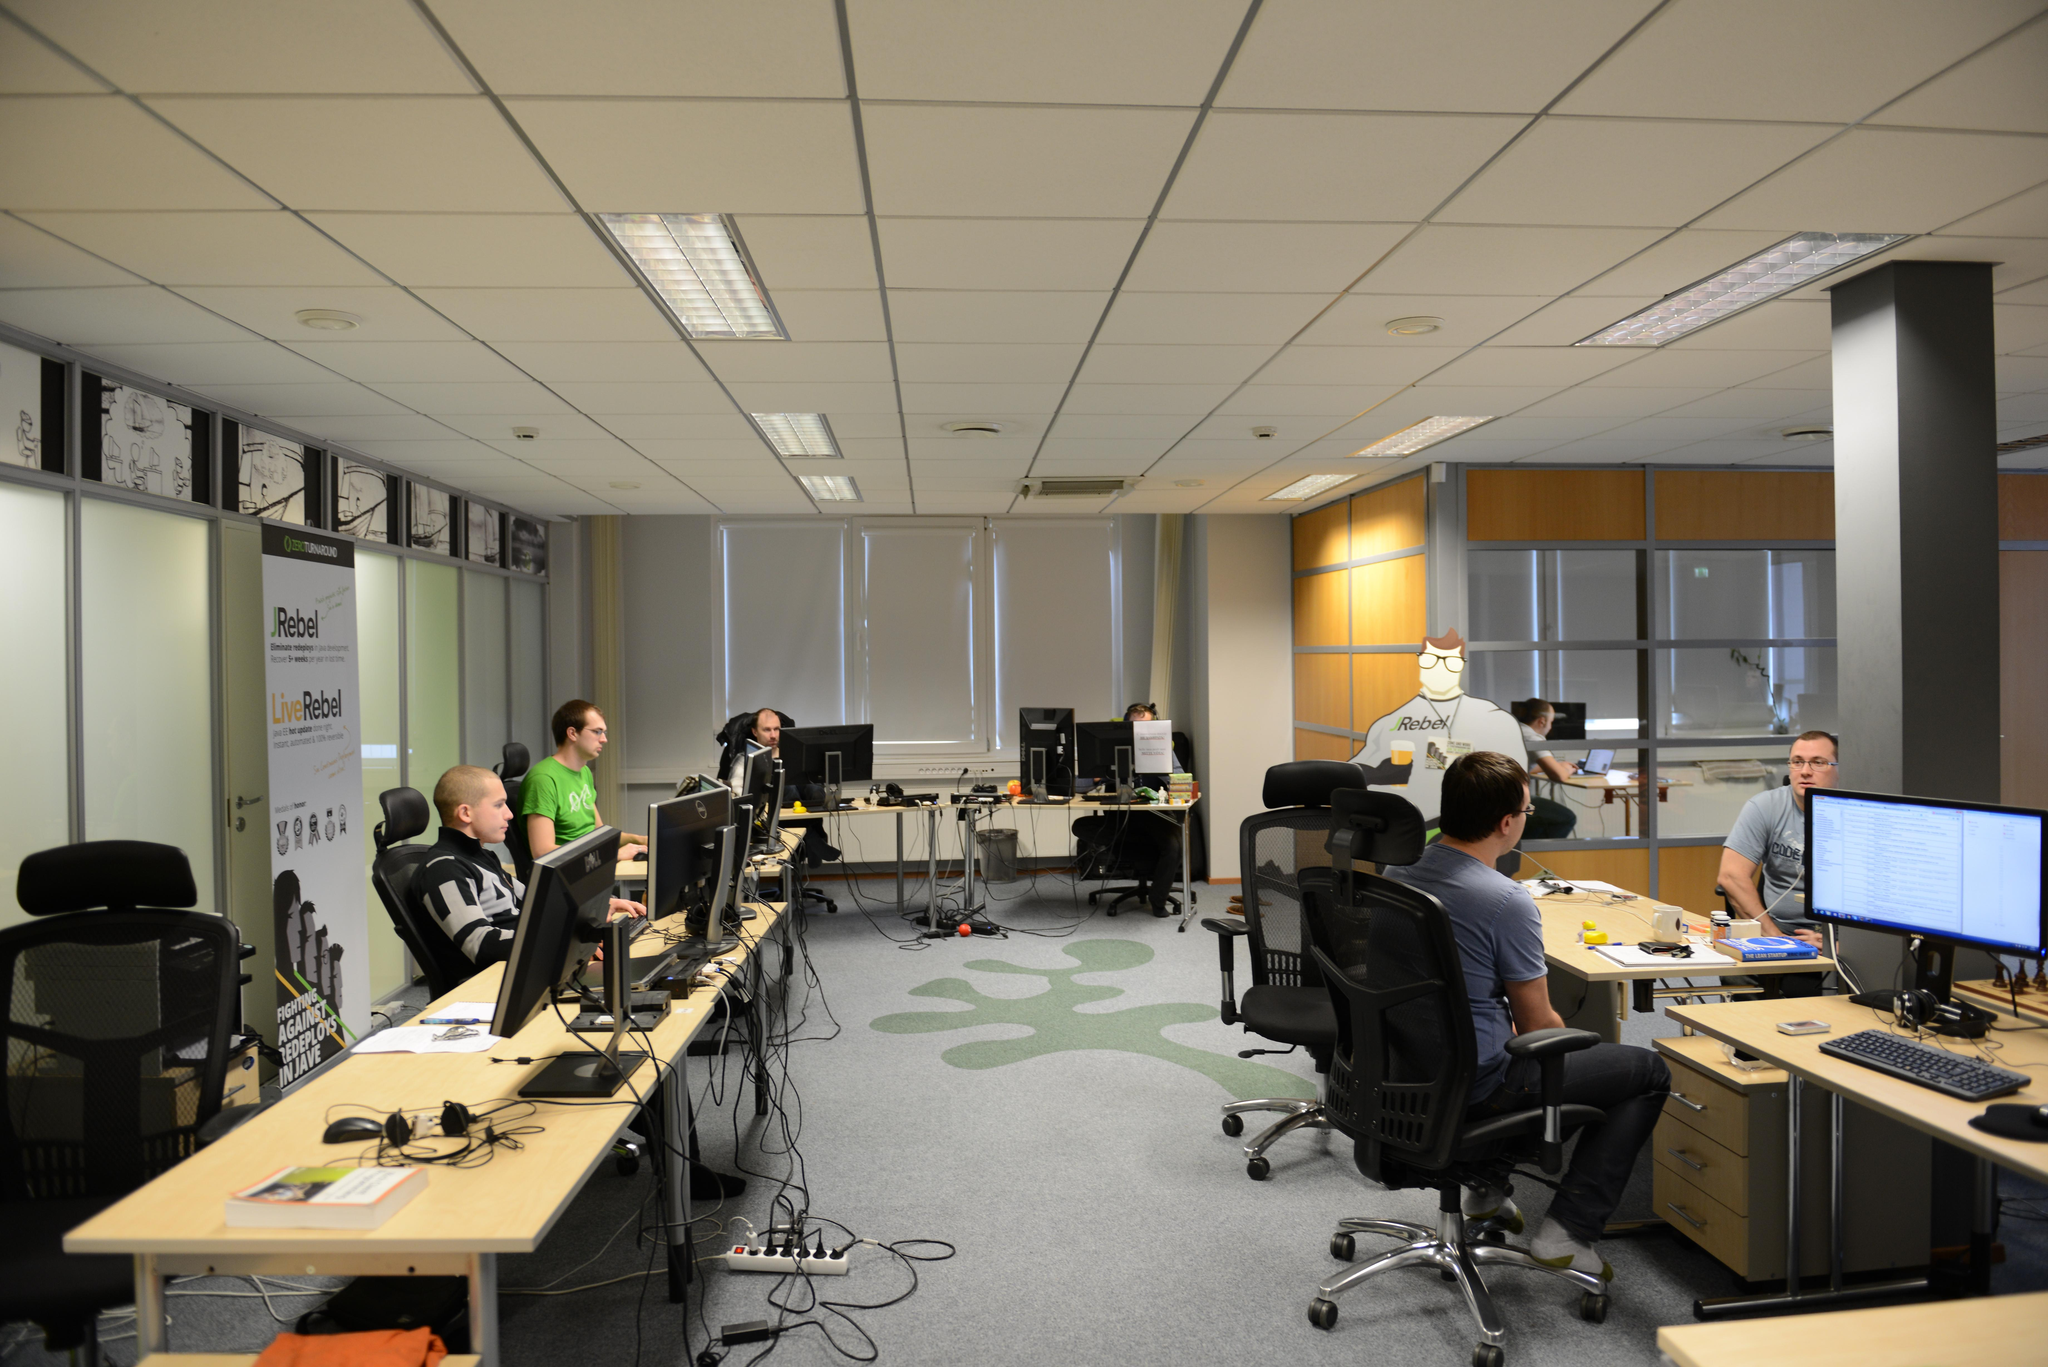How many people are in the image? There are people in the image. What are the people doing in the image? The people are sitting in front of a computer. What might the people be doing while sitting in front of the computer? The people are working. What type of beef is being cooked in the image? There is no beef present in the image; it features people sitting in front of a computer. Can you tell me how many toothbrushes are visible in the image? There are no toothbrushes visible in the image; it features people sitting in front of a computer. 